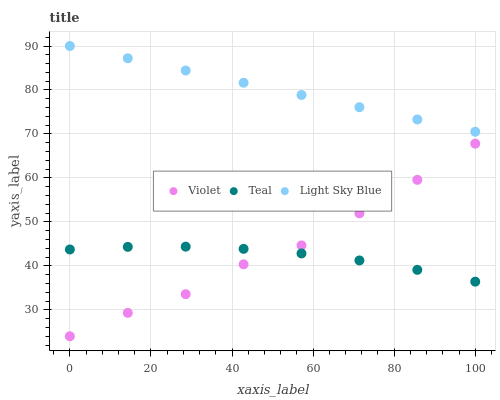Does Teal have the minimum area under the curve?
Answer yes or no. Yes. Does Light Sky Blue have the maximum area under the curve?
Answer yes or no. Yes. Does Violet have the minimum area under the curve?
Answer yes or no. No. Does Violet have the maximum area under the curve?
Answer yes or no. No. Is Light Sky Blue the smoothest?
Answer yes or no. Yes. Is Violet the roughest?
Answer yes or no. Yes. Is Teal the smoothest?
Answer yes or no. No. Is Teal the roughest?
Answer yes or no. No. Does Violet have the lowest value?
Answer yes or no. Yes. Does Teal have the lowest value?
Answer yes or no. No. Does Light Sky Blue have the highest value?
Answer yes or no. Yes. Does Violet have the highest value?
Answer yes or no. No. Is Teal less than Light Sky Blue?
Answer yes or no. Yes. Is Light Sky Blue greater than Violet?
Answer yes or no. Yes. Does Teal intersect Violet?
Answer yes or no. Yes. Is Teal less than Violet?
Answer yes or no. No. Is Teal greater than Violet?
Answer yes or no. No. Does Teal intersect Light Sky Blue?
Answer yes or no. No. 